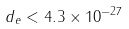<formula> <loc_0><loc_0><loc_500><loc_500>d _ { e } < 4 . 3 \times 1 0 ^ { - 2 7 }</formula> 